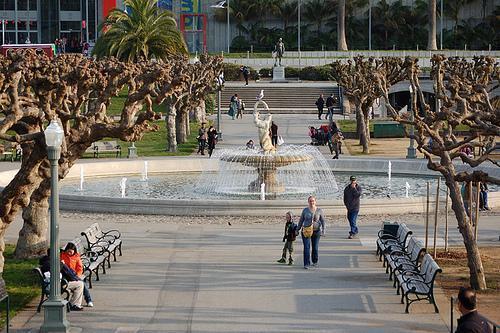How many benches are there?
Give a very brief answer. 8. How many people are sitting on a bench?
Give a very brief answer. 2. 